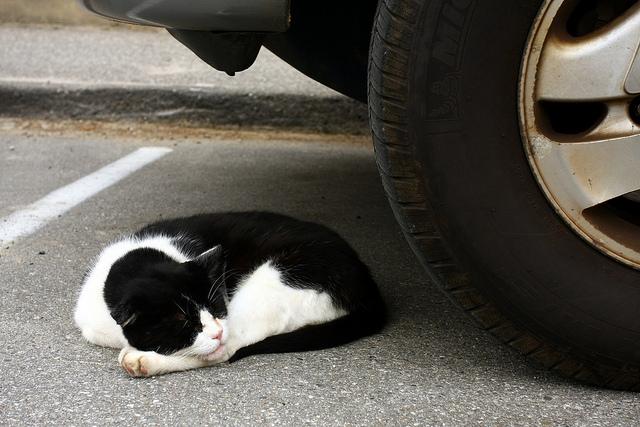What color is the cat?
Be succinct. Black and white. Is the cat behind the vehicle?
Give a very brief answer. Yes. What is the percentage of black fur to white fur on the cat?
Give a very brief answer. 50. 